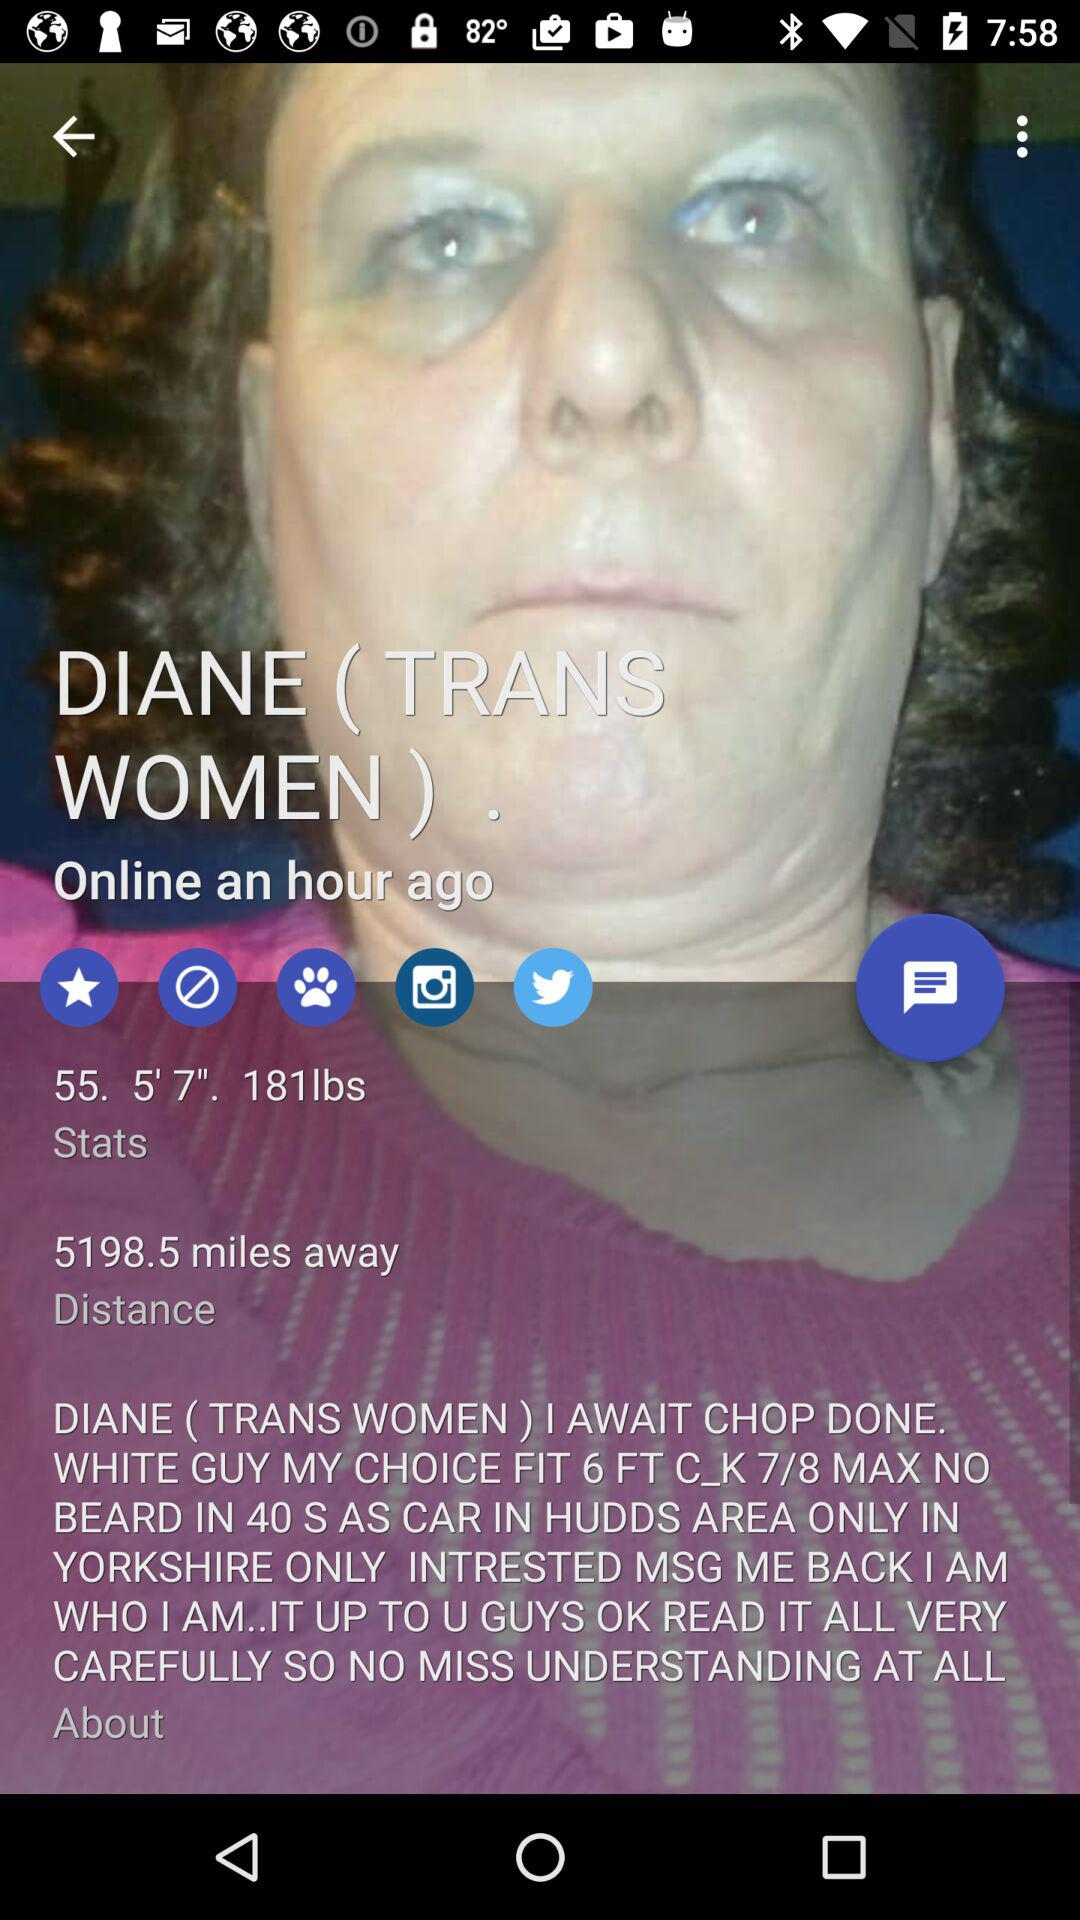What is the height? The height is 5 feet 7 inches. 